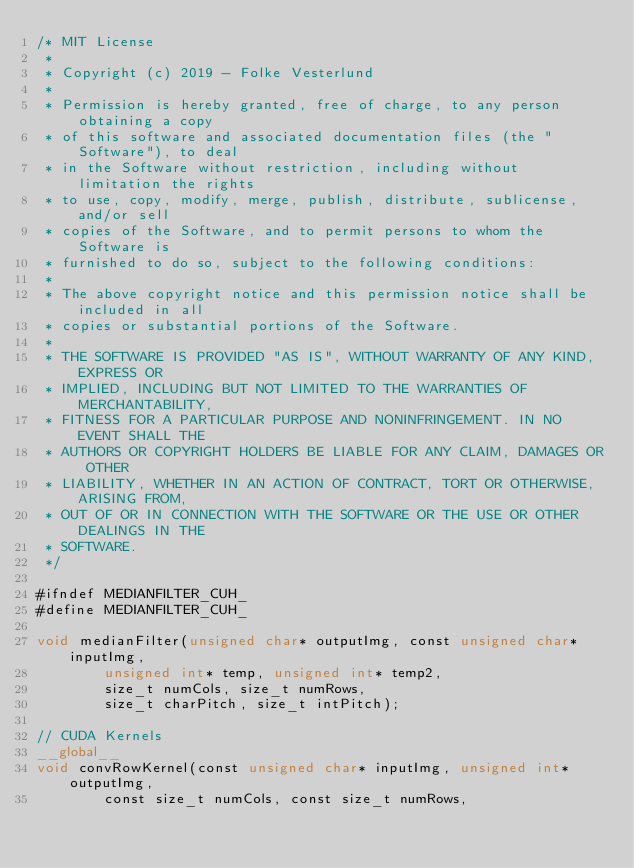Convert code to text. <code><loc_0><loc_0><loc_500><loc_500><_Cuda_>/* MIT License
 *
 * Copyright (c) 2019 - Folke Vesterlund
 *
 * Permission is hereby granted, free of charge, to any person obtaining a copy
 * of this software and associated documentation files (the "Software"), to deal
 * in the Software without restriction, including without limitation the rights
 * to use, copy, modify, merge, publish, distribute, sublicense, and/or sell
 * copies of the Software, and to permit persons to whom the Software is
 * furnished to do so, subject to the following conditions:
 *
 * The above copyright notice and this permission notice shall be included in all
 * copies or substantial portions of the Software.
 *
 * THE SOFTWARE IS PROVIDED "AS IS", WITHOUT WARRANTY OF ANY KIND, EXPRESS OR
 * IMPLIED, INCLUDING BUT NOT LIMITED TO THE WARRANTIES OF MERCHANTABILITY,
 * FITNESS FOR A PARTICULAR PURPOSE AND NONINFRINGEMENT. IN NO EVENT SHALL THE
 * AUTHORS OR COPYRIGHT HOLDERS BE LIABLE FOR ANY CLAIM, DAMAGES OR OTHER
 * LIABILITY, WHETHER IN AN ACTION OF CONTRACT, TORT OR OTHERWISE, ARISING FROM,
 * OUT OF OR IN CONNECTION WITH THE SOFTWARE OR THE USE OR OTHER DEALINGS IN THE
 * SOFTWARE.
 */

#ifndef MEDIANFILTER_CUH_
#define MEDIANFILTER_CUH_

void medianFilter(unsigned char* outputImg, const unsigned char* inputImg,
		unsigned int* temp, unsigned int* temp2,
		size_t numCols, size_t numRows,
		size_t charPitch, size_t intPitch);

// CUDA Kernels
__global__
void convRowKernel(const unsigned char* inputImg, unsigned int* outputImg,
		const size_t numCols, const size_t numRows,</code> 